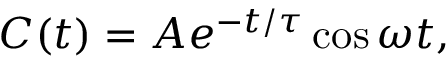<formula> <loc_0><loc_0><loc_500><loc_500>C ( t ) = A e ^ { - t / \tau } \cos \omega t ,</formula> 